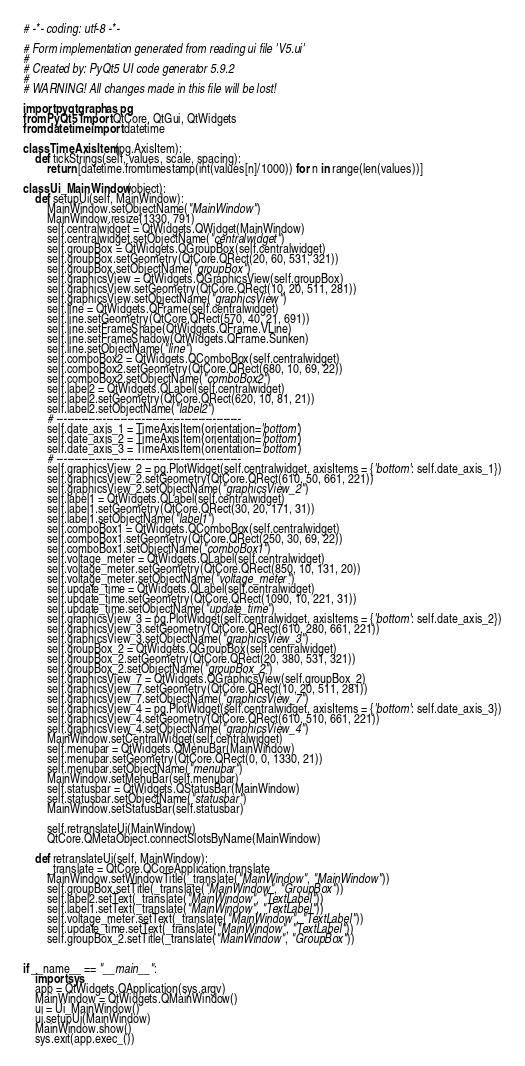<code> <loc_0><loc_0><loc_500><loc_500><_Python_># -*- coding: utf-8 -*-

# Form implementation generated from reading ui file 'V5.ui'
#
# Created by: PyQt5 UI code generator 5.9.2
#
# WARNING! All changes made in this file will be lost!

import pyqtgraph as pg
from PyQt5 import QtCore, QtGui, QtWidgets
from datetime import datetime

class TimeAxisItem(pg.AxisItem):
    def tickStrings(self, values, scale, spacing):
        return [datetime.fromtimestamp(int(values[n]/1000)) for n in range(len(values))]

class Ui_MainWindow(object):
    def setupUi(self, MainWindow):
        MainWindow.setObjectName("MainWindow")
        MainWindow.resize(1330, 791)
        self.centralwidget = QtWidgets.QWidget(MainWindow)
        self.centralwidget.setObjectName("centralwidget")
        self.groupBox = QtWidgets.QGroupBox(self.centralwidget)
        self.groupBox.setGeometry(QtCore.QRect(20, 60, 531, 321))
        self.groupBox.setObjectName("groupBox")
        self.graphicsView = QtWidgets.QGraphicsView(self.groupBox)
        self.graphicsView.setGeometry(QtCore.QRect(10, 20, 511, 281))
        self.graphicsView.setObjectName("graphicsView")
        self.line = QtWidgets.QFrame(self.centralwidget)
        self.line.setGeometry(QtCore.QRect(570, 40, 21, 691))
        self.line.setFrameShape(QtWidgets.QFrame.VLine)
        self.line.setFrameShadow(QtWidgets.QFrame.Sunken)
        self.line.setObjectName("line")
        self.comboBox2 = QtWidgets.QComboBox(self.centralwidget)
        self.comboBox2.setGeometry(QtCore.QRect(680, 10, 69, 22))
        self.comboBox2.setObjectName("comboBox2")
        self.label2 = QtWidgets.QLabel(self.centralwidget)
        self.label2.setGeometry(QtCore.QRect(620, 10, 81, 21))
        self.label2.setObjectName("label2")
        # ----------------------------------------------------
        self.date_axis_1 = TimeAxisItem(orientation='bottom')
        self.date_axis_2 = TimeAxisItem(orientation='bottom')
        self.date_axis_3 = TimeAxisItem(orientation='bottom')
        # ----------------------------------------------------
        self.graphicsView_2 = pg.PlotWidget(self.centralwidget, axisItems = {'bottom': self.date_axis_1})
        self.graphicsView_2.setGeometry(QtCore.QRect(610, 50, 661, 221))
        self.graphicsView_2.setObjectName("graphicsView_2")
        self.label1 = QtWidgets.QLabel(self.centralwidget)
        self.label1.setGeometry(QtCore.QRect(30, 20, 171, 31))
        self.label1.setObjectName("label1")
        self.comboBox1 = QtWidgets.QComboBox(self.centralwidget)
        self.comboBox1.setGeometry(QtCore.QRect(250, 30, 69, 22))
        self.comboBox1.setObjectName("comboBox1")
        self.voltage_meter = QtWidgets.QLabel(self.centralwidget)
        self.voltage_meter.setGeometry(QtCore.QRect(850, 10, 131, 20))
        self.voltage_meter.setObjectName("voltage_meter")
        self.update_time = QtWidgets.QLabel(self.centralwidget)
        self.update_time.setGeometry(QtCore.QRect(1090, 10, 221, 31))
        self.update_time.setObjectName("update_time")
        self.graphicsView_3 = pg.PlotWidget(self.centralwidget, axisItems = {'bottom': self.date_axis_2})
        self.graphicsView_3.setGeometry(QtCore.QRect(610, 280, 661, 221))
        self.graphicsView_3.setObjectName("graphicsView_3")
        self.groupBox_2 = QtWidgets.QGroupBox(self.centralwidget)
        self.groupBox_2.setGeometry(QtCore.QRect(20, 380, 531, 321))
        self.groupBox_2.setObjectName("groupBox_2")
        self.graphicsView_7 = QtWidgets.QGraphicsView(self.groupBox_2)
        self.graphicsView_7.setGeometry(QtCore.QRect(10, 20, 511, 281))
        self.graphicsView_7.setObjectName("graphicsView_7")
        self.graphicsView_4 = pg.PlotWidget(self.centralwidget, axisItems = {'bottom': self.date_axis_3})
        self.graphicsView_4.setGeometry(QtCore.QRect(610, 510, 661, 221))
        self.graphicsView_4.setObjectName("graphicsView_4")
        MainWindow.setCentralWidget(self.centralwidget)
        self.menubar = QtWidgets.QMenuBar(MainWindow)
        self.menubar.setGeometry(QtCore.QRect(0, 0, 1330, 21))
        self.menubar.setObjectName("menubar")
        MainWindow.setMenuBar(self.menubar)
        self.statusbar = QtWidgets.QStatusBar(MainWindow)
        self.statusbar.setObjectName("statusbar")
        MainWindow.setStatusBar(self.statusbar)

        self.retranslateUi(MainWindow)
        QtCore.QMetaObject.connectSlotsByName(MainWindow)

    def retranslateUi(self, MainWindow):
        _translate = QtCore.QCoreApplication.translate
        MainWindow.setWindowTitle(_translate("MainWindow", "MainWindow"))
        self.groupBox.setTitle(_translate("MainWindow", "GroupBox"))
        self.label2.setText(_translate("MainWindow", "TextLabel"))
        self.label1.setText(_translate("MainWindow", "TextLabel"))
        self.voltage_meter.setText(_translate("MainWindow", "TextLabel"))
        self.update_time.setText(_translate("MainWindow", "TextLabel"))
        self.groupBox_2.setTitle(_translate("MainWindow", "GroupBox"))


if __name__ == "__main__":
    import sys
    app = QtWidgets.QApplication(sys.argv)
    MainWindow = QtWidgets.QMainWindow()
    ui = Ui_MainWindow()
    ui.setupUi(MainWindow)
    MainWindow.show()
    sys.exit(app.exec_())

</code> 